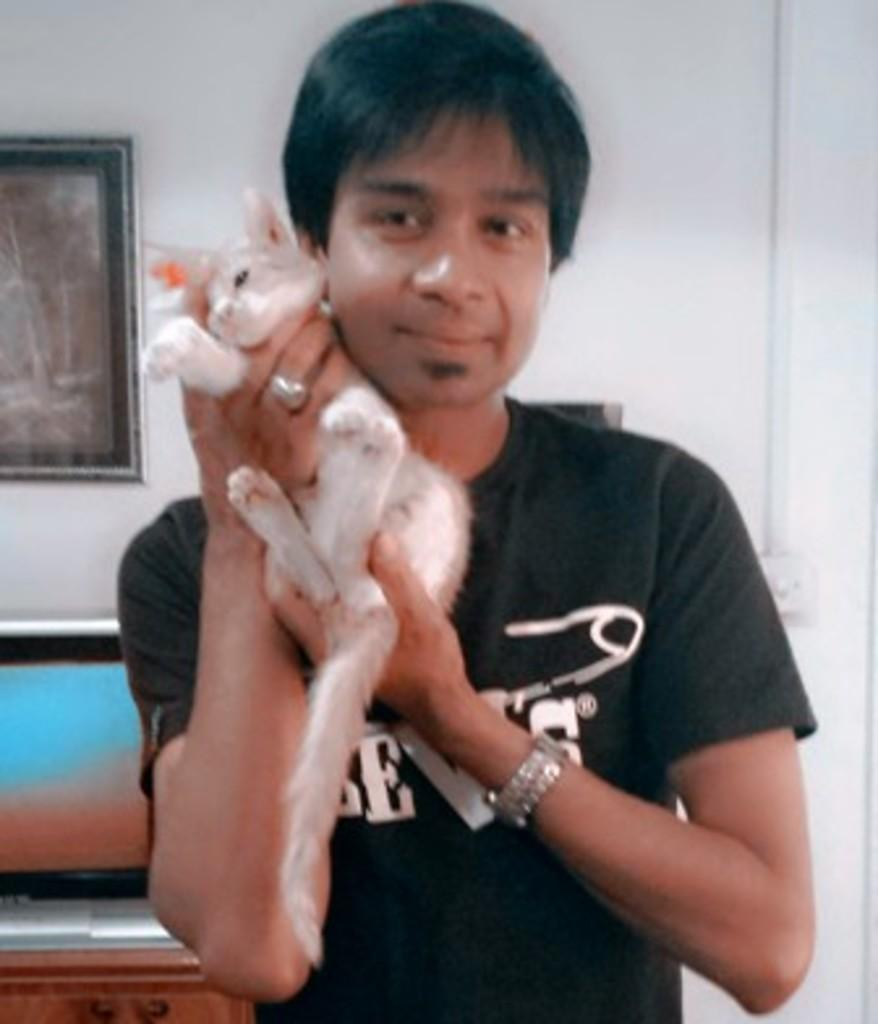What is the main subject of the image? The main subject of the image is a man. What is the man doing in the image? The man is standing and holding a cat in his hands. Can you describe any other objects or features in the image? There is a frame on the wall in the image. What type of music is the ant playing in the image? There is no ant or music present in the image. Can you see any stars in the image? There are no stars visible in the image. 